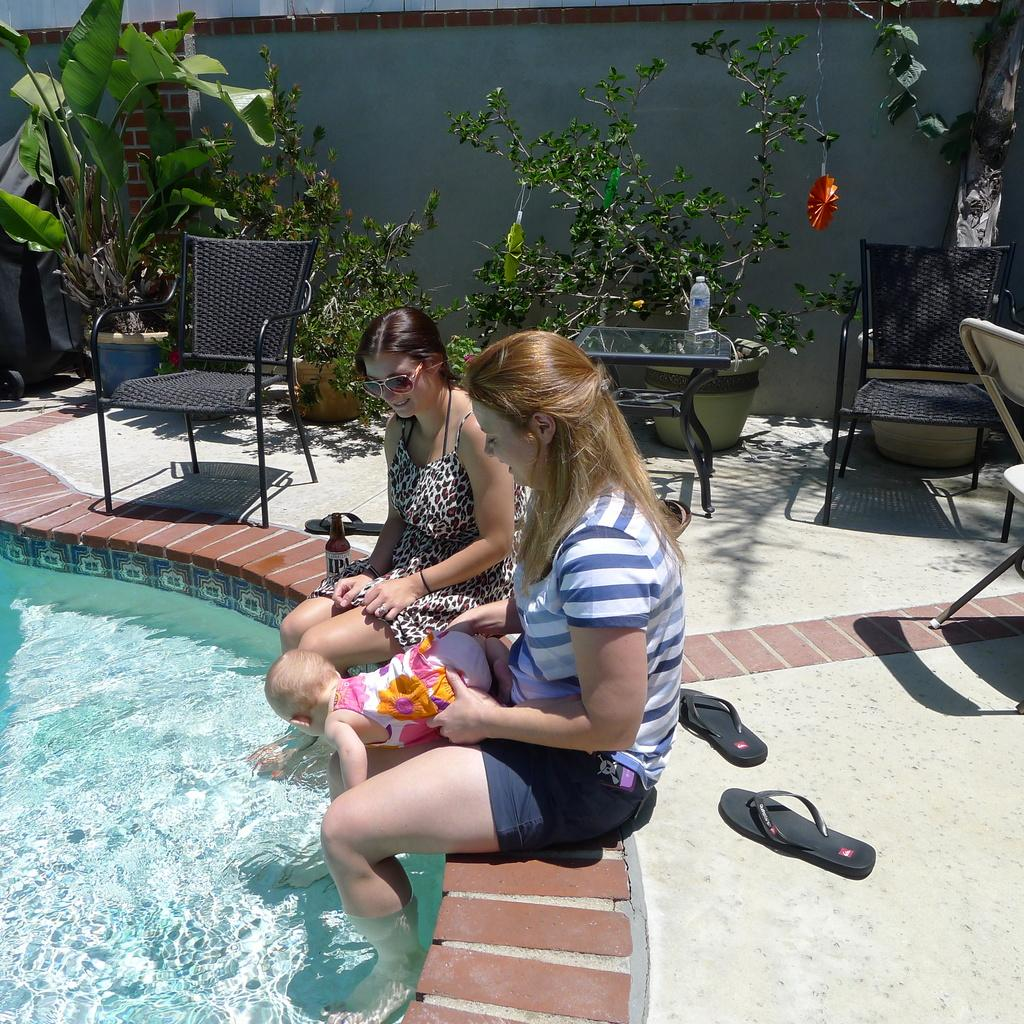What are the women in the image doing? The women are sitting on the pavement of the pool and holding a baby. What can be seen in the background of the image? There are plants, chairs, side tables, slippers, and walls in the background of the image. What type of stitch is the queen using to mend her dress in the image? There is no queen or dress present in the image, and therefore no stitching can be observed. 